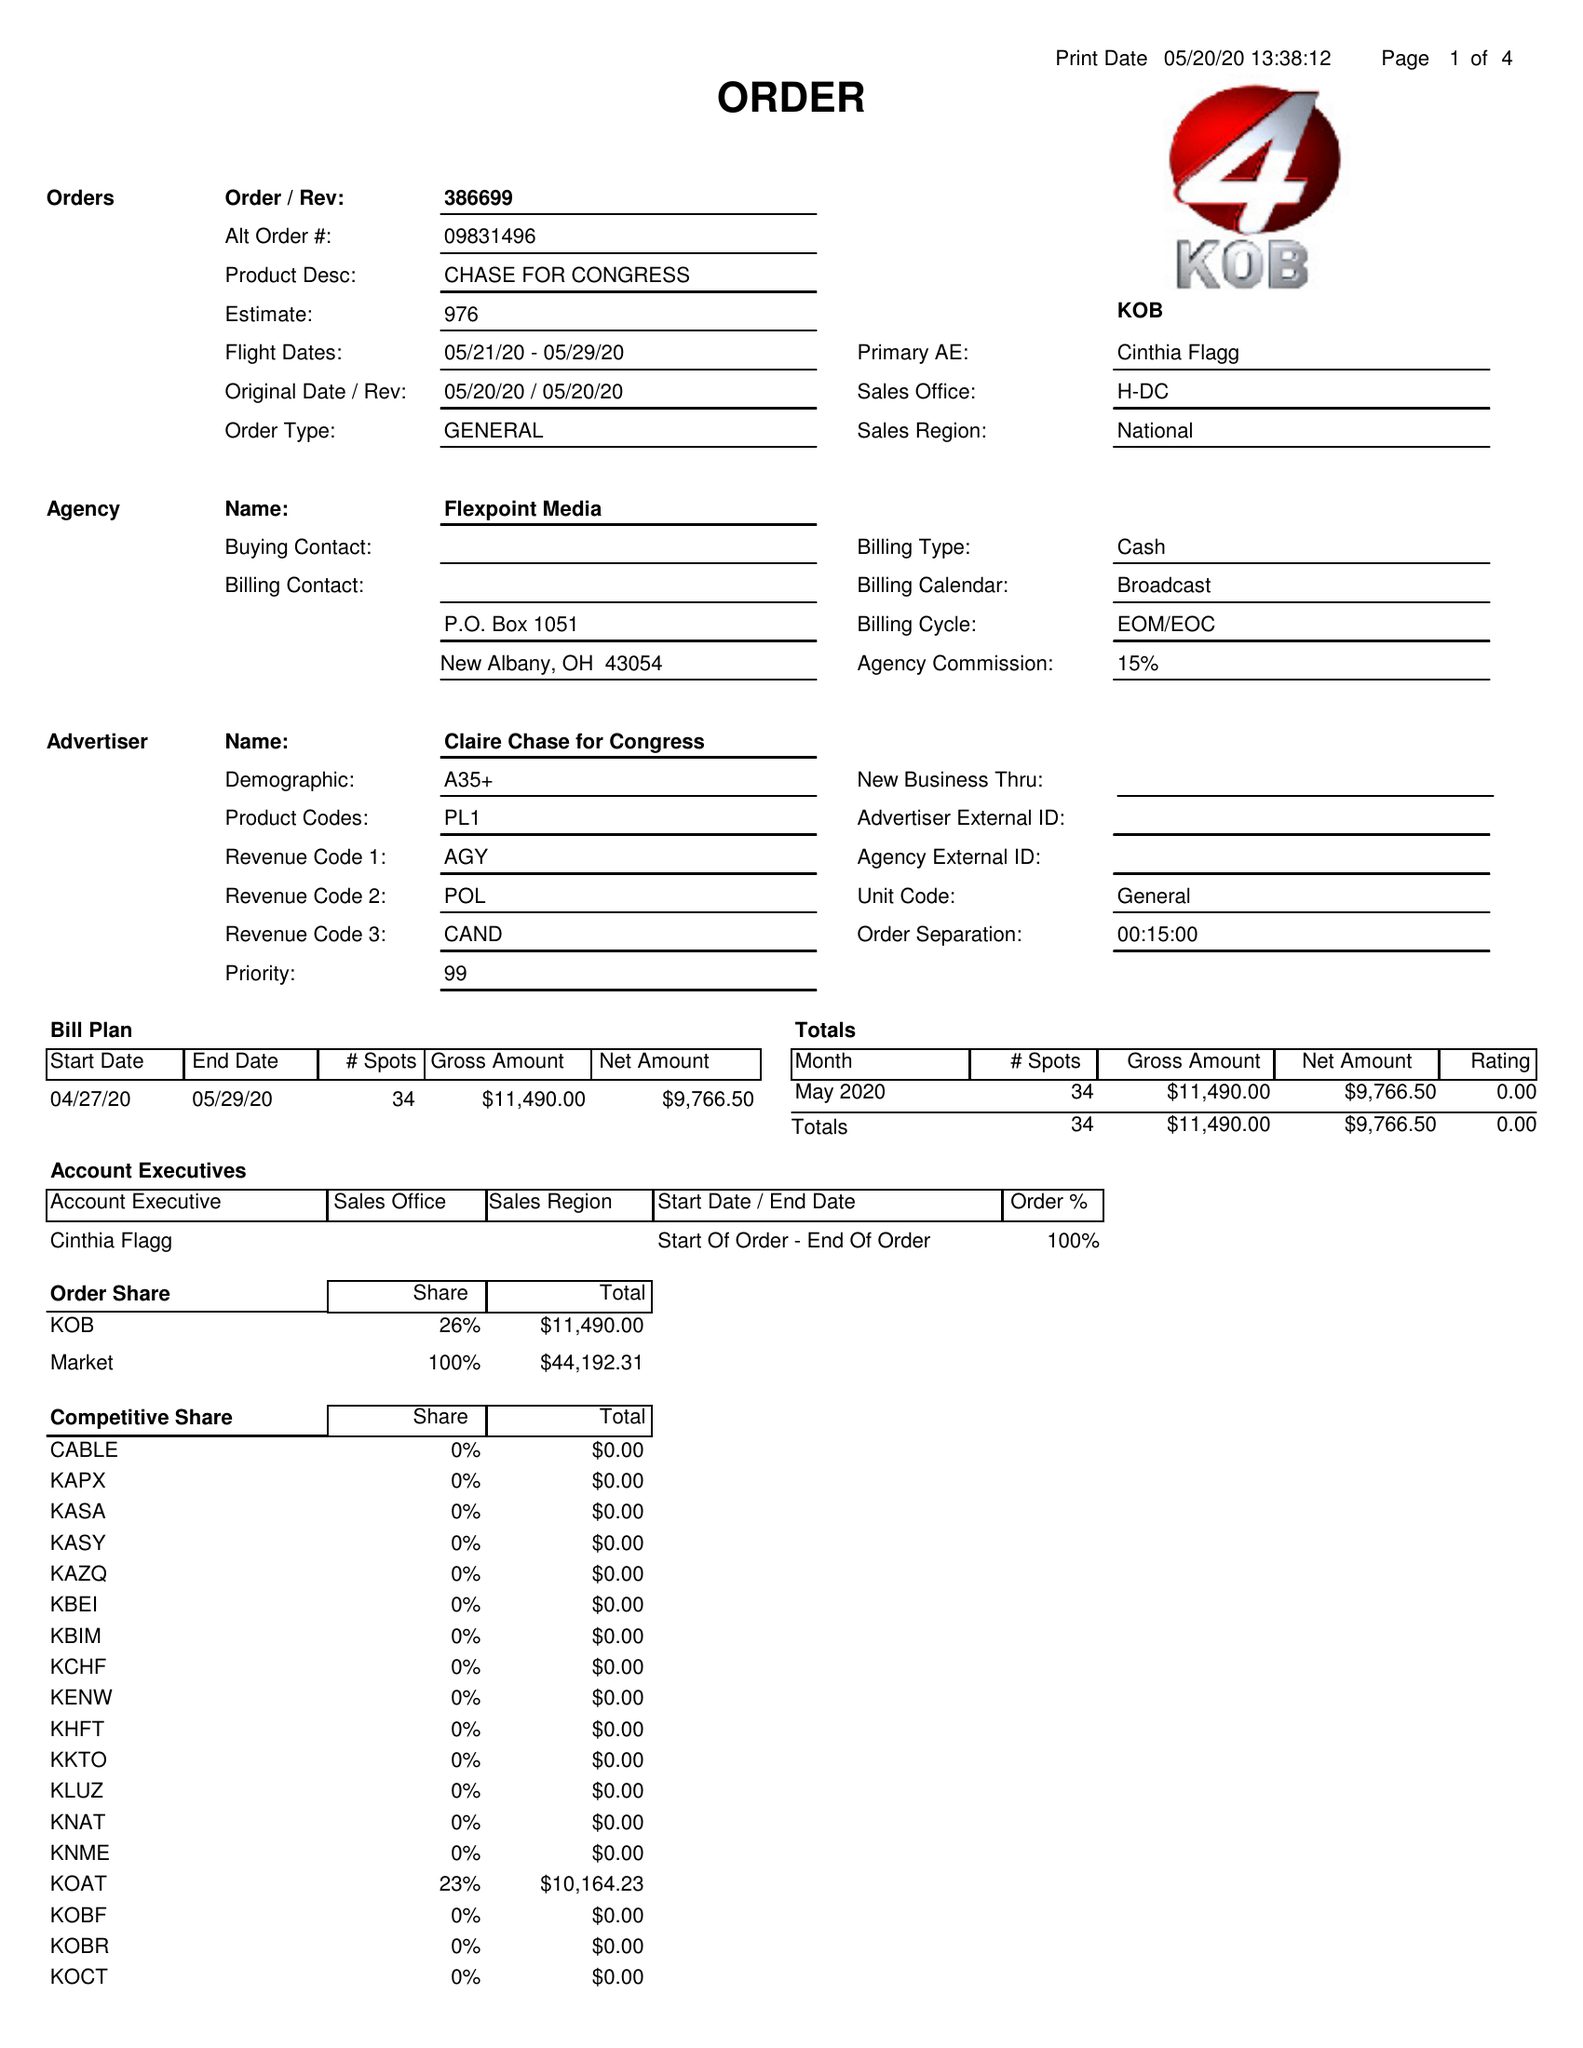What is the value for the gross_amount?
Answer the question using a single word or phrase. 11490.00 